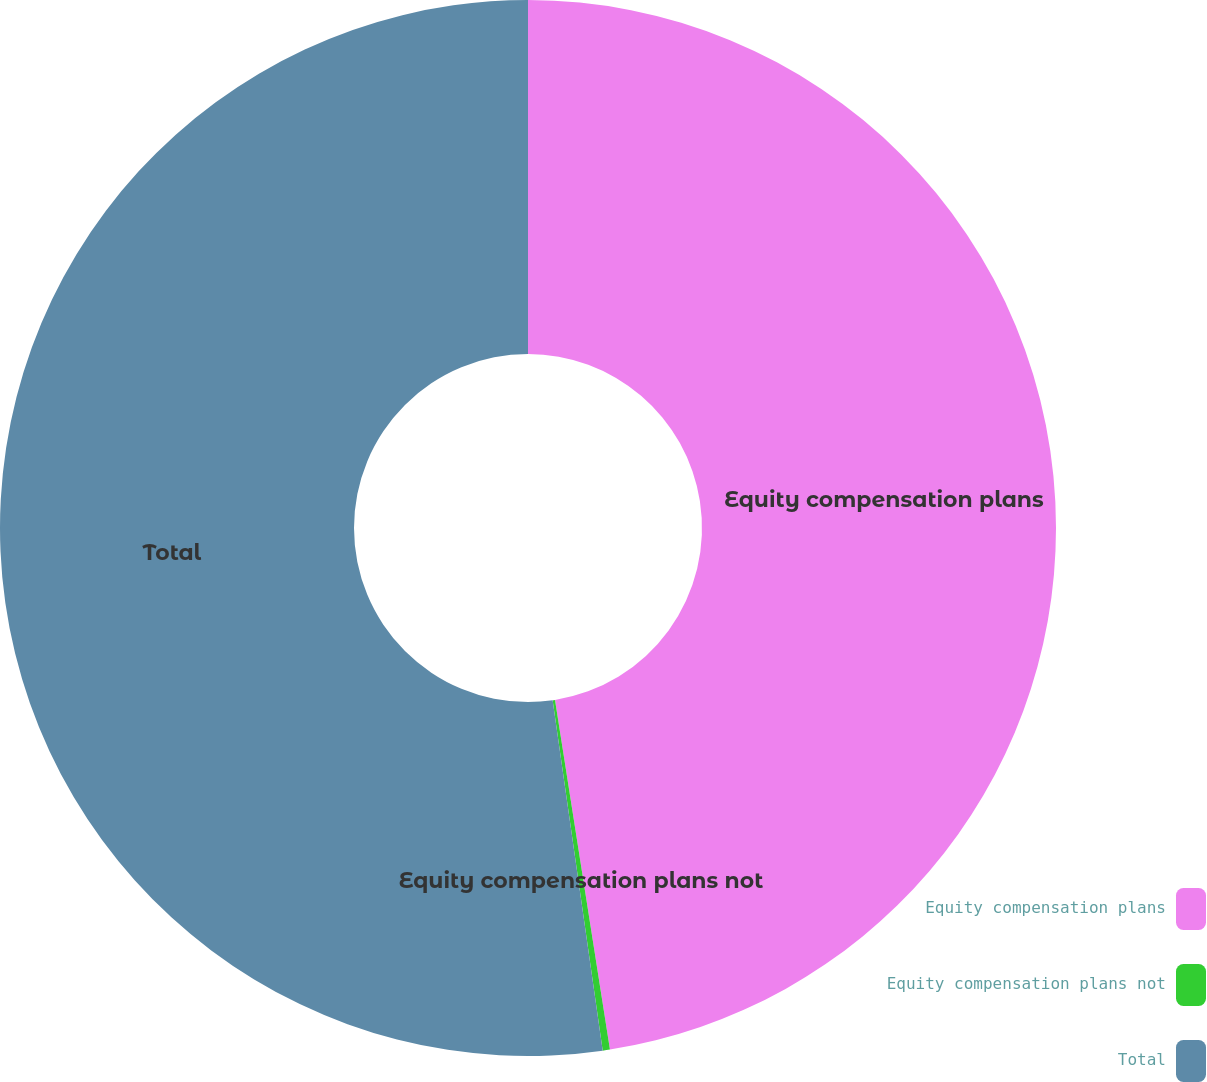Convert chart. <chart><loc_0><loc_0><loc_500><loc_500><pie_chart><fcel>Equity compensation plans<fcel>Equity compensation plans not<fcel>Total<nl><fcel>47.52%<fcel>0.22%<fcel>52.26%<nl></chart> 